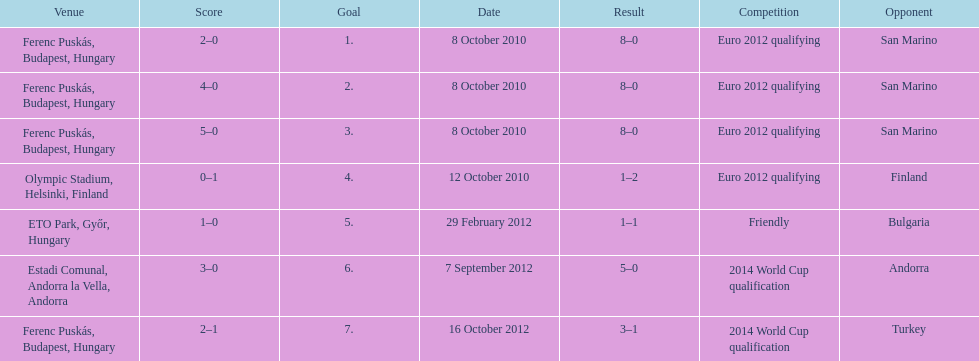What is the overall count of international goals scored by ádám szalai? 7. 